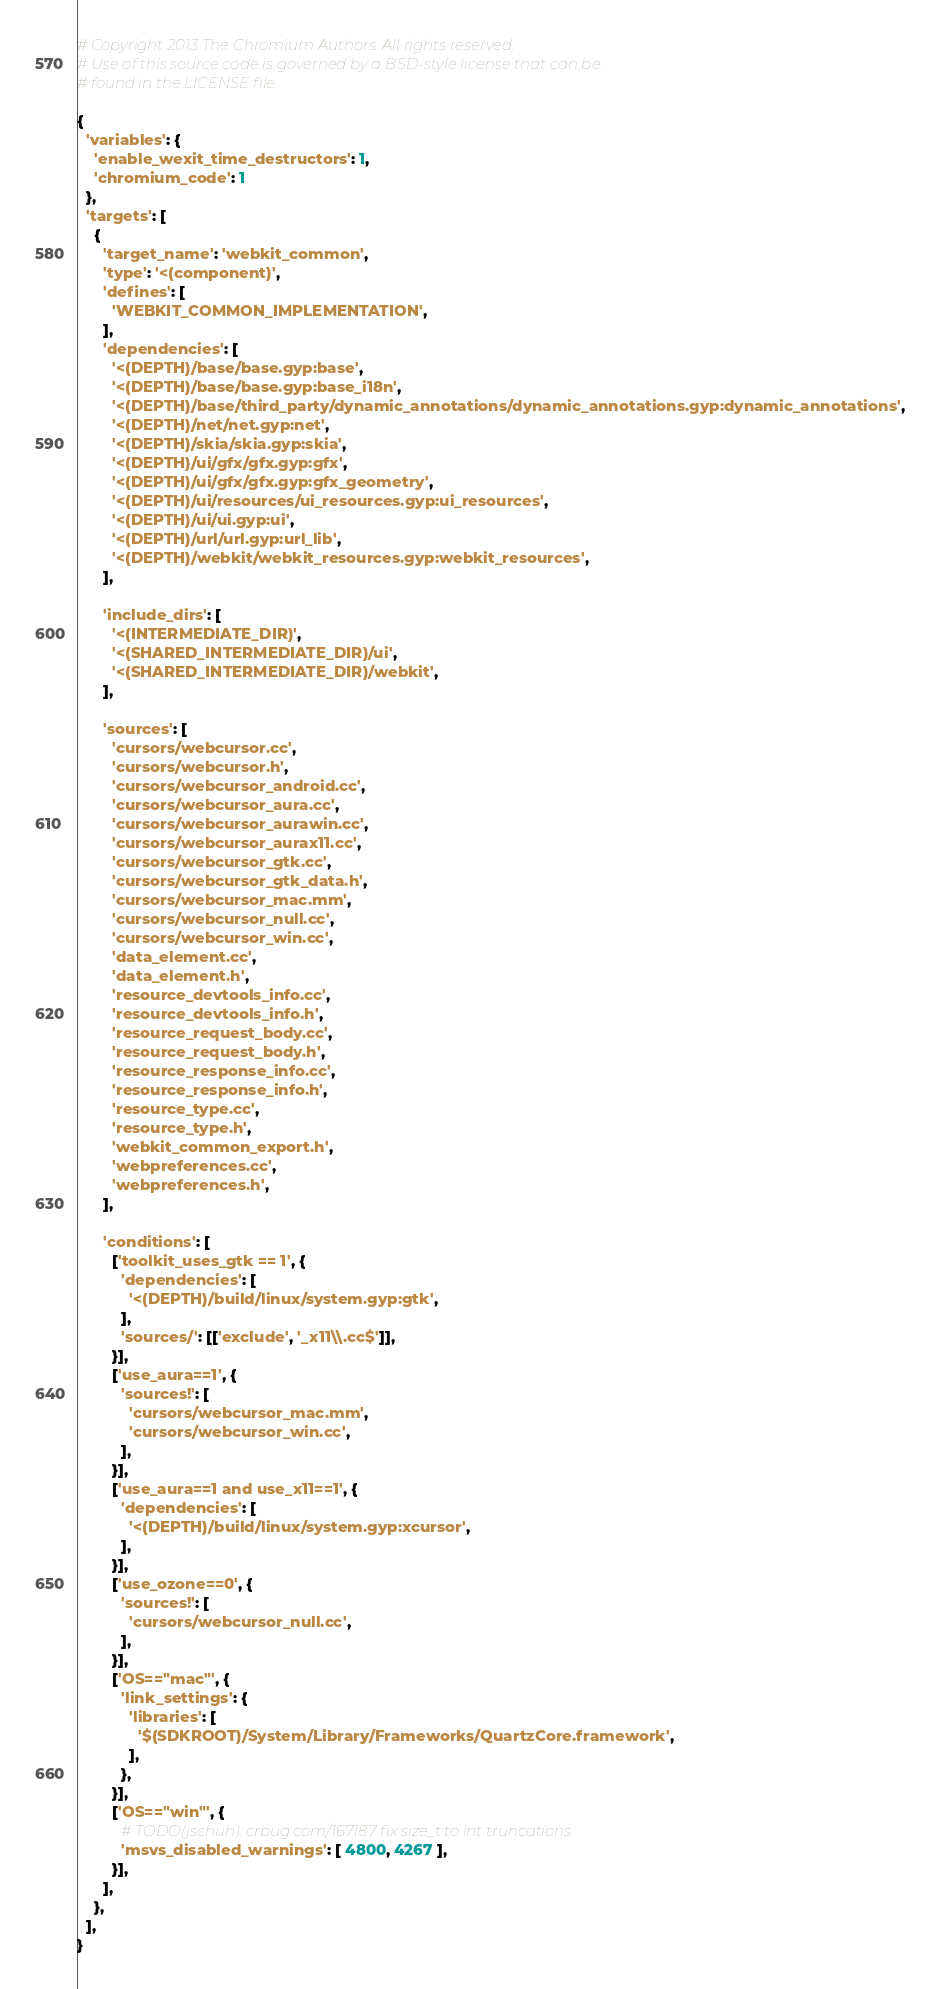Convert code to text. <code><loc_0><loc_0><loc_500><loc_500><_Python_># Copyright 2013 The Chromium Authors. All rights reserved.
# Use of this source code is governed by a BSD-style license that can be
# found in the LICENSE file.

{
  'variables': {
    'enable_wexit_time_destructors': 1,
    'chromium_code': 1
  },
  'targets': [
    {
      'target_name': 'webkit_common',
      'type': '<(component)',
      'defines': [
        'WEBKIT_COMMON_IMPLEMENTATION',
      ],
      'dependencies': [
        '<(DEPTH)/base/base.gyp:base',
        '<(DEPTH)/base/base.gyp:base_i18n',
        '<(DEPTH)/base/third_party/dynamic_annotations/dynamic_annotations.gyp:dynamic_annotations',
        '<(DEPTH)/net/net.gyp:net',
        '<(DEPTH)/skia/skia.gyp:skia',
        '<(DEPTH)/ui/gfx/gfx.gyp:gfx',
        '<(DEPTH)/ui/gfx/gfx.gyp:gfx_geometry',
        '<(DEPTH)/ui/resources/ui_resources.gyp:ui_resources',
        '<(DEPTH)/ui/ui.gyp:ui',
        '<(DEPTH)/url/url.gyp:url_lib',
        '<(DEPTH)/webkit/webkit_resources.gyp:webkit_resources',
      ],

      'include_dirs': [
        '<(INTERMEDIATE_DIR)',
        '<(SHARED_INTERMEDIATE_DIR)/ui',
        '<(SHARED_INTERMEDIATE_DIR)/webkit',
      ],

      'sources': [
        'cursors/webcursor.cc',
        'cursors/webcursor.h',
        'cursors/webcursor_android.cc',
        'cursors/webcursor_aura.cc',
        'cursors/webcursor_aurawin.cc',
        'cursors/webcursor_aurax11.cc',
        'cursors/webcursor_gtk.cc',
        'cursors/webcursor_gtk_data.h',
        'cursors/webcursor_mac.mm',
        'cursors/webcursor_null.cc',
        'cursors/webcursor_win.cc',
        'data_element.cc',
        'data_element.h',
        'resource_devtools_info.cc',
        'resource_devtools_info.h',
        'resource_request_body.cc',
        'resource_request_body.h',
        'resource_response_info.cc',
        'resource_response_info.h',
        'resource_type.cc',
        'resource_type.h',
        'webkit_common_export.h',
        'webpreferences.cc',
        'webpreferences.h',
      ],

      'conditions': [
        ['toolkit_uses_gtk == 1', {
          'dependencies': [
            '<(DEPTH)/build/linux/system.gyp:gtk',
          ],
          'sources/': [['exclude', '_x11\\.cc$']],
        }],
        ['use_aura==1', {
          'sources!': [
            'cursors/webcursor_mac.mm',
            'cursors/webcursor_win.cc',
          ],
        }],
        ['use_aura==1 and use_x11==1', {
          'dependencies': [
            '<(DEPTH)/build/linux/system.gyp:xcursor',
          ],
        }],
        ['use_ozone==0', {
          'sources!': [
            'cursors/webcursor_null.cc',
          ],
        }],
        ['OS=="mac"', {
          'link_settings': {
            'libraries': [
              '$(SDKROOT)/System/Library/Frameworks/QuartzCore.framework',
            ],
          },
        }],
        ['OS=="win"', {
          # TODO(jschuh): crbug.com/167187 fix size_t to int truncations.
          'msvs_disabled_warnings': [ 4800, 4267 ],
        }],
      ],
    },
  ],
}
</code> 